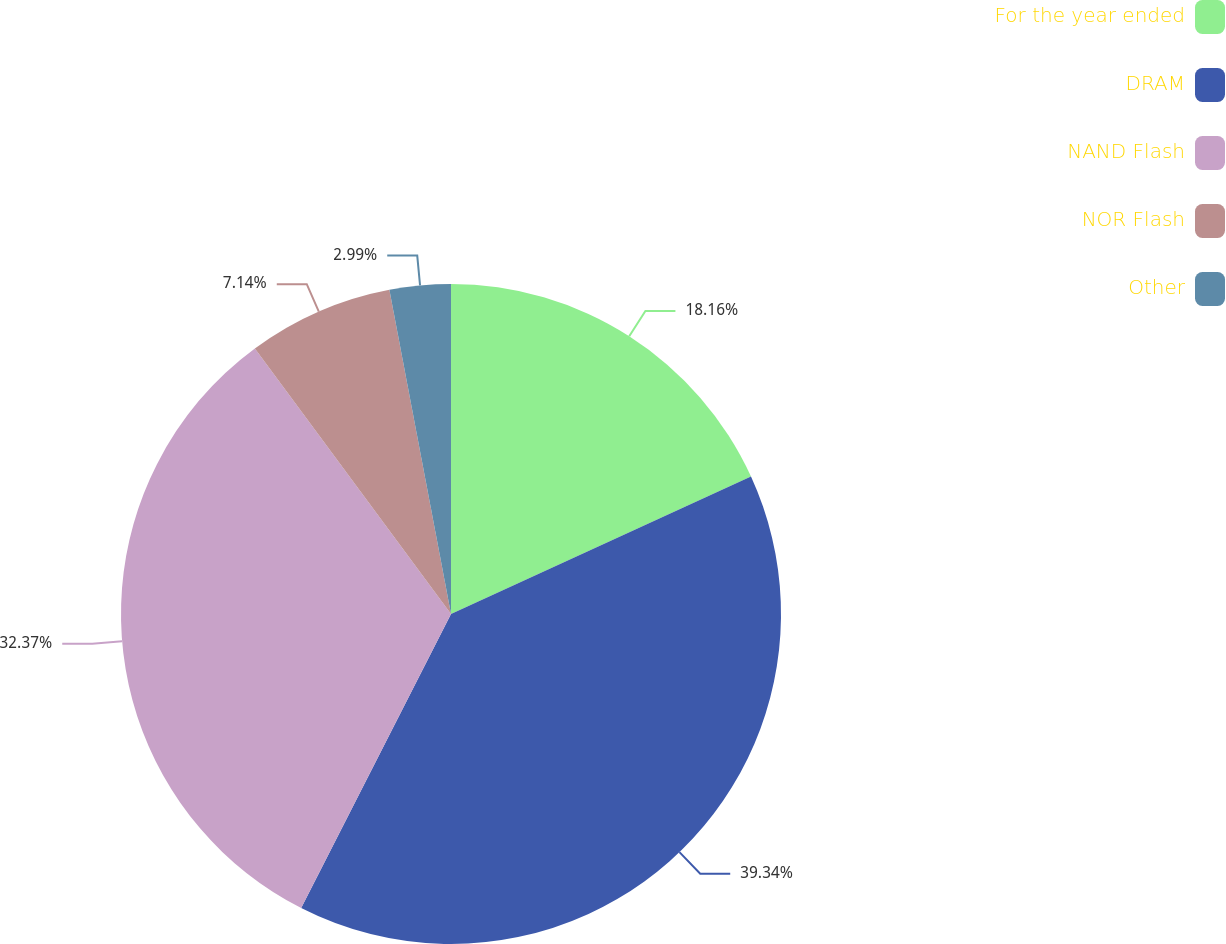Convert chart. <chart><loc_0><loc_0><loc_500><loc_500><pie_chart><fcel>For the year ended<fcel>DRAM<fcel>NAND Flash<fcel>NOR Flash<fcel>Other<nl><fcel>18.16%<fcel>39.34%<fcel>32.37%<fcel>7.14%<fcel>2.99%<nl></chart> 